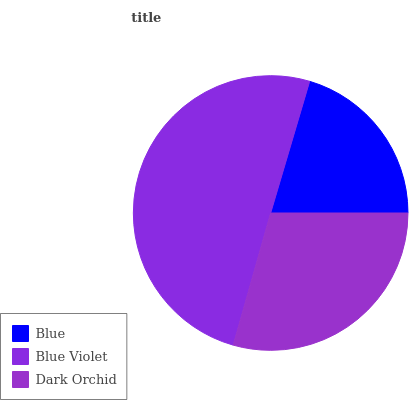Is Blue the minimum?
Answer yes or no. Yes. Is Blue Violet the maximum?
Answer yes or no. Yes. Is Dark Orchid the minimum?
Answer yes or no. No. Is Dark Orchid the maximum?
Answer yes or no. No. Is Blue Violet greater than Dark Orchid?
Answer yes or no. Yes. Is Dark Orchid less than Blue Violet?
Answer yes or no. Yes. Is Dark Orchid greater than Blue Violet?
Answer yes or no. No. Is Blue Violet less than Dark Orchid?
Answer yes or no. No. Is Dark Orchid the high median?
Answer yes or no. Yes. Is Dark Orchid the low median?
Answer yes or no. Yes. Is Blue the high median?
Answer yes or no. No. Is Blue the low median?
Answer yes or no. No. 